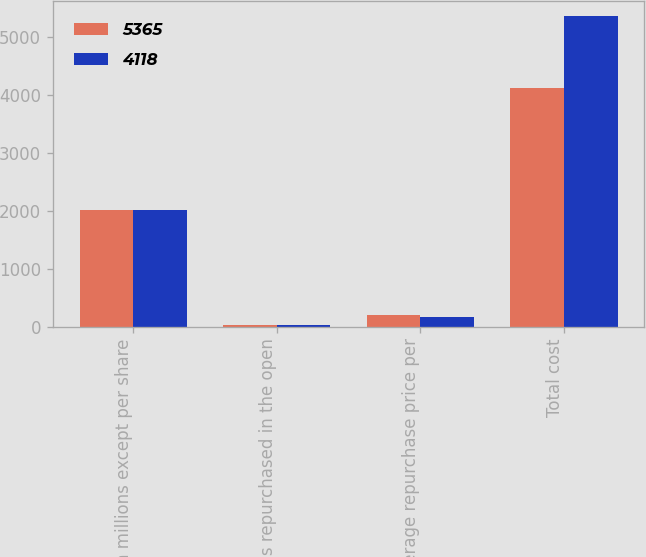Convert chart to OTSL. <chart><loc_0><loc_0><loc_500><loc_500><stacked_bar_chart><ecel><fcel>(in millions except per share<fcel>Shares repurchased in the open<fcel>Average repurchase price per<fcel>Total cost<nl><fcel>5365<fcel>2014<fcel>20<fcel>208.5<fcel>4118<nl><fcel>4118<fcel>2013<fcel>33<fcel>161.94<fcel>5365<nl></chart> 